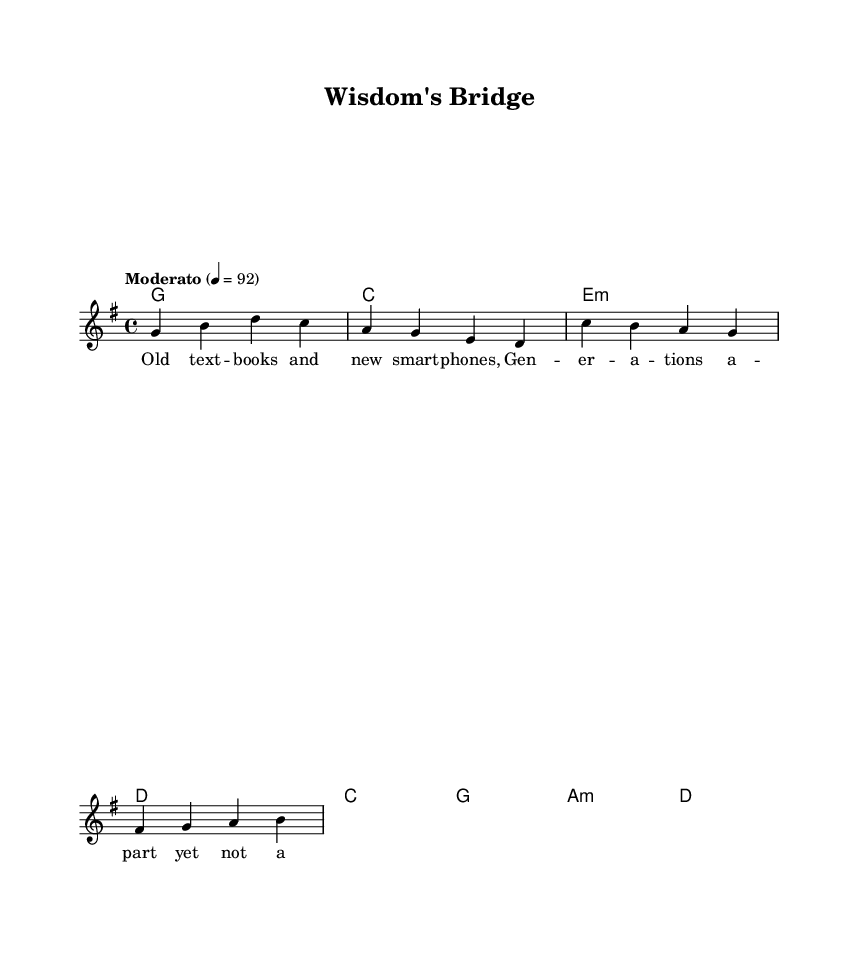What is the key signature of this music? The key signature is indicated in the global section as "g \major", which corresponds to one sharp (F#).
Answer: G major What is the time signature of this music? The time signature is specified in the global section as "4/4", which indicates there are four beats in a measure and a quarter note receives one beat.
Answer: 4/4 What is the tempo marking for the piece? The tempo marking states "Moderato" with a metronome marking of "4 = 92", meaning the piece should be played at a moderate speed of 92 beats per minute.
Answer: Moderato 4 = 92 How many measures are in the verse? Counting the measures in the melody section, there are four measures present in the verse before the chorus begins.
Answer: 4 What is the first note of the chorus? Referring to the melody, the chorus starts with the note "C", which is indicated at the beginning of the chorus section.
Answer: C What is the underlying chord for the first measure of the verse? The first chord written in the harmonies section for the verse is "g1", indicating it is a G major chord played for one whole note.
Answer: G What is the main theme expressed in the lyrics of the song? The lyrics express themes of connection across generations and igniting the potential of young minds, as seen in phrases like "Bridge the gap, light the spark".
Answer: Bridging generational gaps 